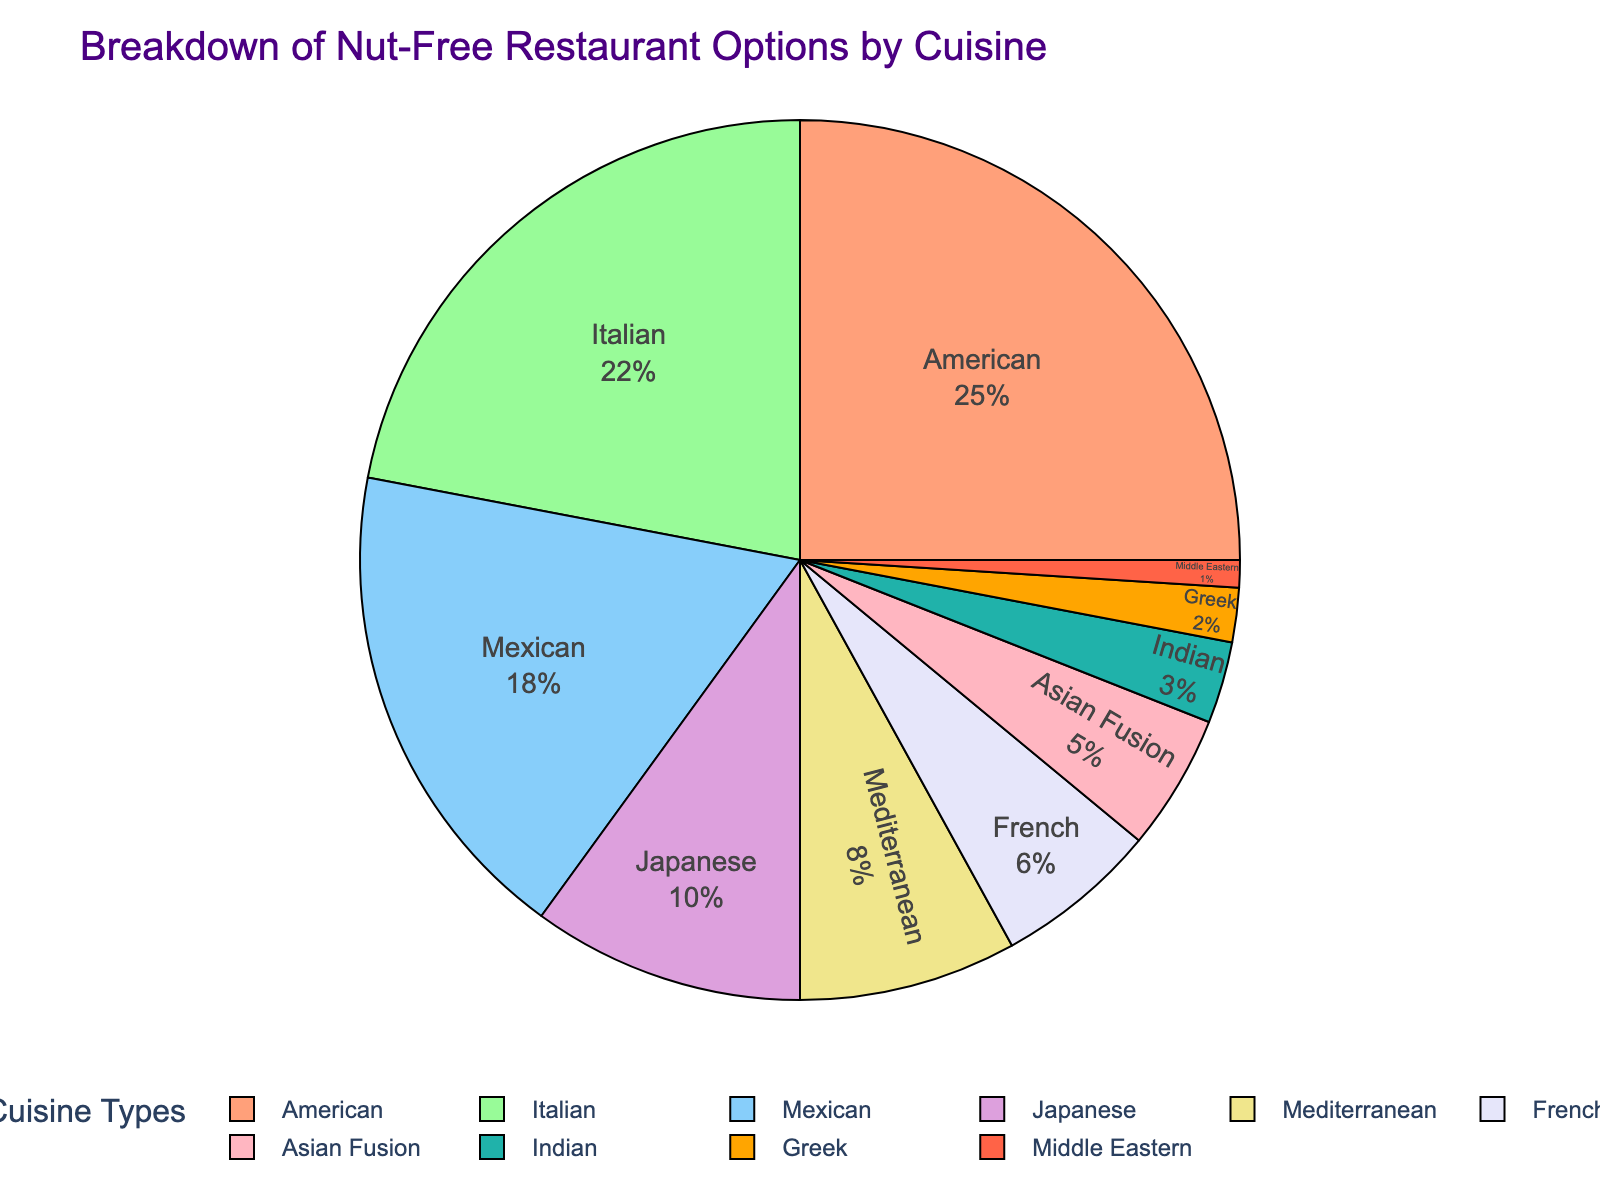Which cuisine occupies the largest segment of the pie chart? The largest segment of the pie chart is represented by the American cuisine segment. We can visually identify it by seeing the proportion of the pie chart it covers compared to the other segments.
Answer: American Which cuisine has a smaller percentage of nut-free options, Greek or Middle Eastern? By comparing the visual sizes of the segments, the Middle Eastern cuisine segment is smaller than the Greek cuisine segment.
Answer: Middle Eastern What is the combined percentage of nut-free options represented by French and Indian cuisines? To find the combined percentage, add the percentages for French (6%) and Indian (3%) cuisines together. The sum is 6% + 3% = 9%.
Answer: 9% How many times larger is the percentage of nut-free options for Japanese cuisine compared to Greek cuisine? Japanese cuisine accounts for 10% while Greek cuisine accounts for 2%. To find how many times larger Japanese's percentage is, divide 10% by 2% which results in 10 / 2 = 5 times larger.
Answer: 5 Which cuisines have a nut-free option percentage of less than 5% each? The cuisines that have less than 5% are Asian Fusion (5%), Indian (3%), Greek (2%), and Middle Eastern (1%).
Answer: Indian, Greek, Middle Eastern Identify the cuisine represented by the greenish segment of the pie chart. The pie chart uses colors to distinguish cuisines. The green color segment represents Asian Fusion cuisine.
Answer: Asian Fusion What is the difference in percentage between Italian and Mexican cuisines? Italian cuisine has a percentage of 22% while Mexican has 18%. Subtract Mexican's percentage from Italian's: 22% - 18% = 4%.
Answer: 4% Which two cuisines combined roughly account for half of the nut-free options? The two highest percentages are American (25%) and Italian (22%). Adding these, 25% + 22% = 47%, which is close to half.
Answer: American, Italian 